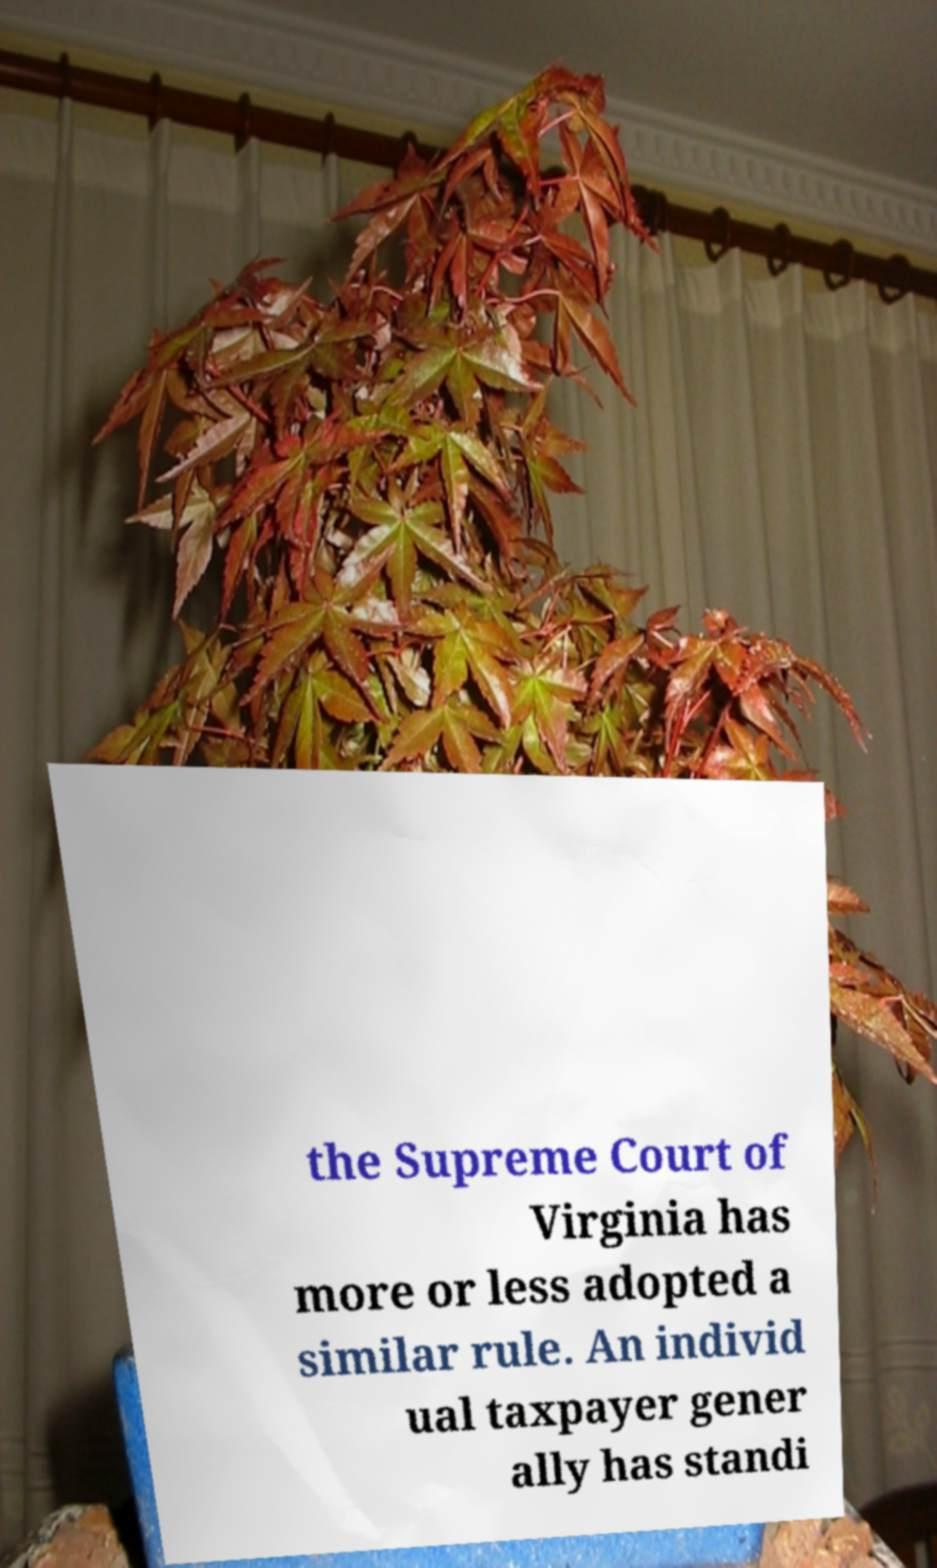There's text embedded in this image that I need extracted. Can you transcribe it verbatim? the Supreme Court of Virginia has more or less adopted a similar rule. An individ ual taxpayer gener ally has standi 